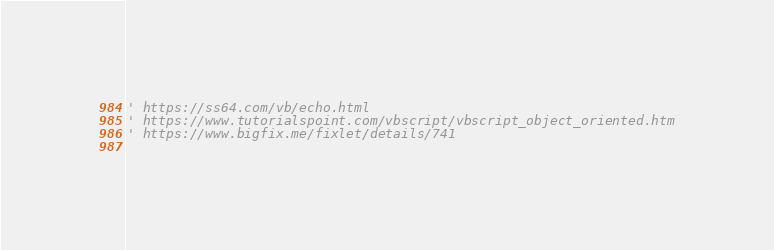Convert code to text. <code><loc_0><loc_0><loc_500><loc_500><_VisualBasic_>' https://ss64.com/vb/echo.html
' https://www.tutorialspoint.com/vbscript/vbscript_object_oriented.htm
' https://www.bigfix.me/fixlet/details/741
    
</code> 